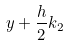Convert formula to latex. <formula><loc_0><loc_0><loc_500><loc_500>y + \frac { h } { 2 } k _ { 2 }</formula> 